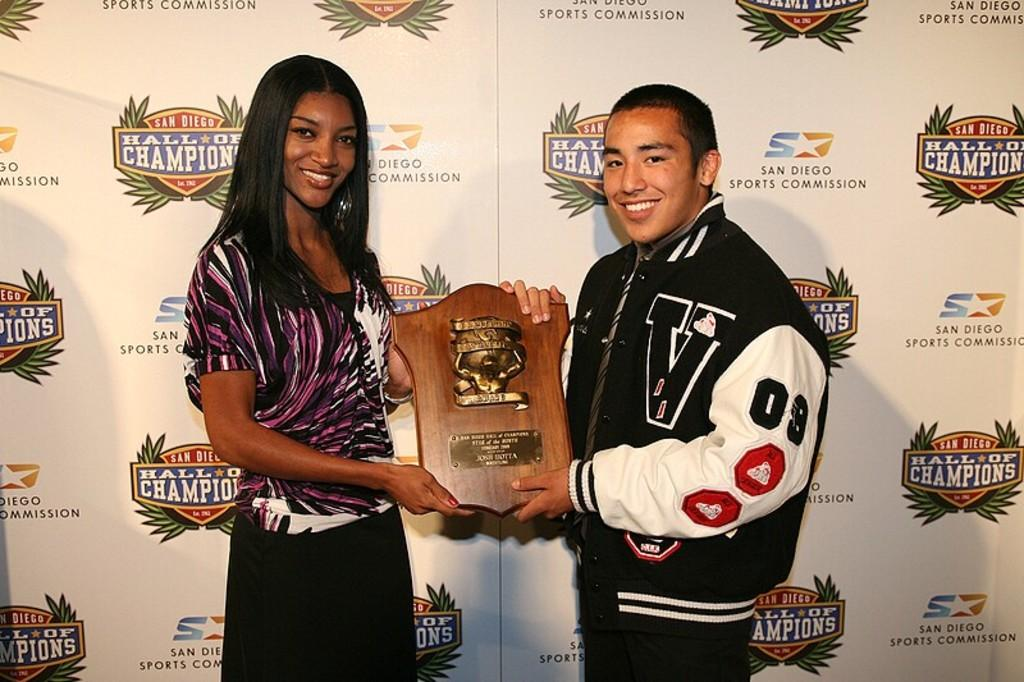Provide a one-sentence caption for the provided image. A young woman and a young man in a varsity jacket stand in front of a backdrop with the San Diego Hall of Champions logo on it. 